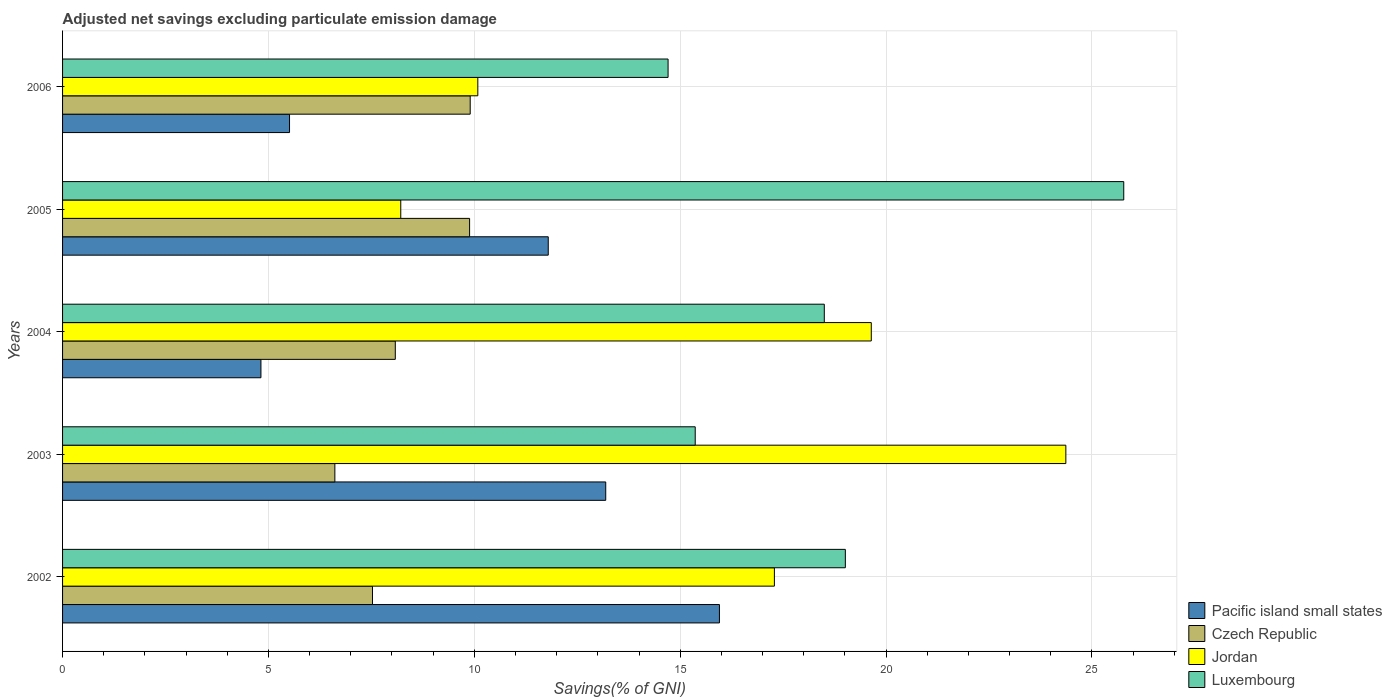How many different coloured bars are there?
Your response must be concise. 4. Are the number of bars per tick equal to the number of legend labels?
Your response must be concise. Yes. How many bars are there on the 1st tick from the top?
Ensure brevity in your answer.  4. What is the adjusted net savings in Luxembourg in 2003?
Make the answer very short. 15.36. Across all years, what is the maximum adjusted net savings in Luxembourg?
Offer a terse response. 25.77. Across all years, what is the minimum adjusted net savings in Czech Republic?
Offer a very short reply. 6.61. What is the total adjusted net savings in Czech Republic in the graph?
Your response must be concise. 42.01. What is the difference between the adjusted net savings in Jordan in 2002 and that in 2003?
Ensure brevity in your answer.  -7.08. What is the difference between the adjusted net savings in Jordan in 2003 and the adjusted net savings in Luxembourg in 2002?
Offer a terse response. 5.36. What is the average adjusted net savings in Jordan per year?
Your answer should be very brief. 15.92. In the year 2004, what is the difference between the adjusted net savings in Luxembourg and adjusted net savings in Pacific island small states?
Offer a terse response. 13.68. In how many years, is the adjusted net savings in Pacific island small states greater than 16 %?
Give a very brief answer. 0. What is the ratio of the adjusted net savings in Luxembourg in 2004 to that in 2005?
Make the answer very short. 0.72. What is the difference between the highest and the second highest adjusted net savings in Czech Republic?
Your response must be concise. 0.01. What is the difference between the highest and the lowest adjusted net savings in Luxembourg?
Make the answer very short. 11.07. In how many years, is the adjusted net savings in Czech Republic greater than the average adjusted net savings in Czech Republic taken over all years?
Offer a very short reply. 2. Is the sum of the adjusted net savings in Pacific island small states in 2004 and 2005 greater than the maximum adjusted net savings in Luxembourg across all years?
Provide a succinct answer. No. What does the 3rd bar from the top in 2006 represents?
Offer a very short reply. Czech Republic. What does the 4th bar from the bottom in 2004 represents?
Make the answer very short. Luxembourg. Are all the bars in the graph horizontal?
Make the answer very short. Yes. How many years are there in the graph?
Make the answer very short. 5. Are the values on the major ticks of X-axis written in scientific E-notation?
Keep it short and to the point. No. Does the graph contain any zero values?
Give a very brief answer. No. Where does the legend appear in the graph?
Give a very brief answer. Bottom right. How many legend labels are there?
Offer a terse response. 4. What is the title of the graph?
Ensure brevity in your answer.  Adjusted net savings excluding particulate emission damage. Does "Tuvalu" appear as one of the legend labels in the graph?
Keep it short and to the point. No. What is the label or title of the X-axis?
Your answer should be very brief. Savings(% of GNI). What is the label or title of the Y-axis?
Your answer should be very brief. Years. What is the Savings(% of GNI) in Pacific island small states in 2002?
Make the answer very short. 15.95. What is the Savings(% of GNI) of Czech Republic in 2002?
Provide a succinct answer. 7.53. What is the Savings(% of GNI) of Jordan in 2002?
Your answer should be compact. 17.29. What is the Savings(% of GNI) in Luxembourg in 2002?
Offer a terse response. 19.01. What is the Savings(% of GNI) in Pacific island small states in 2003?
Your response must be concise. 13.19. What is the Savings(% of GNI) of Czech Republic in 2003?
Provide a short and direct response. 6.61. What is the Savings(% of GNI) in Jordan in 2003?
Make the answer very short. 24.37. What is the Savings(% of GNI) of Luxembourg in 2003?
Your response must be concise. 15.36. What is the Savings(% of GNI) of Pacific island small states in 2004?
Provide a succinct answer. 4.82. What is the Savings(% of GNI) of Czech Republic in 2004?
Make the answer very short. 8.08. What is the Savings(% of GNI) of Jordan in 2004?
Make the answer very short. 19.64. What is the Savings(% of GNI) of Luxembourg in 2004?
Your response must be concise. 18.5. What is the Savings(% of GNI) in Pacific island small states in 2005?
Keep it short and to the point. 11.8. What is the Savings(% of GNI) of Czech Republic in 2005?
Offer a terse response. 9.89. What is the Savings(% of GNI) of Jordan in 2005?
Offer a terse response. 8.21. What is the Savings(% of GNI) in Luxembourg in 2005?
Offer a very short reply. 25.77. What is the Savings(% of GNI) of Pacific island small states in 2006?
Make the answer very short. 5.51. What is the Savings(% of GNI) in Czech Republic in 2006?
Give a very brief answer. 9.9. What is the Savings(% of GNI) of Jordan in 2006?
Offer a very short reply. 10.08. What is the Savings(% of GNI) of Luxembourg in 2006?
Give a very brief answer. 14.71. Across all years, what is the maximum Savings(% of GNI) in Pacific island small states?
Make the answer very short. 15.95. Across all years, what is the maximum Savings(% of GNI) of Czech Republic?
Provide a succinct answer. 9.9. Across all years, what is the maximum Savings(% of GNI) of Jordan?
Provide a short and direct response. 24.37. Across all years, what is the maximum Savings(% of GNI) in Luxembourg?
Provide a short and direct response. 25.77. Across all years, what is the minimum Savings(% of GNI) in Pacific island small states?
Make the answer very short. 4.82. Across all years, what is the minimum Savings(% of GNI) of Czech Republic?
Provide a short and direct response. 6.61. Across all years, what is the minimum Savings(% of GNI) in Jordan?
Give a very brief answer. 8.21. Across all years, what is the minimum Savings(% of GNI) of Luxembourg?
Your answer should be compact. 14.71. What is the total Savings(% of GNI) of Pacific island small states in the graph?
Provide a short and direct response. 51.27. What is the total Savings(% of GNI) of Czech Republic in the graph?
Your answer should be very brief. 42.01. What is the total Savings(% of GNI) of Jordan in the graph?
Your answer should be very brief. 79.59. What is the total Savings(% of GNI) in Luxembourg in the graph?
Your answer should be compact. 93.35. What is the difference between the Savings(% of GNI) of Pacific island small states in 2002 and that in 2003?
Your answer should be compact. 2.76. What is the difference between the Savings(% of GNI) of Czech Republic in 2002 and that in 2003?
Offer a terse response. 0.91. What is the difference between the Savings(% of GNI) in Jordan in 2002 and that in 2003?
Keep it short and to the point. -7.08. What is the difference between the Savings(% of GNI) in Luxembourg in 2002 and that in 2003?
Ensure brevity in your answer.  3.65. What is the difference between the Savings(% of GNI) of Pacific island small states in 2002 and that in 2004?
Keep it short and to the point. 11.14. What is the difference between the Savings(% of GNI) of Czech Republic in 2002 and that in 2004?
Offer a terse response. -0.55. What is the difference between the Savings(% of GNI) in Jordan in 2002 and that in 2004?
Provide a succinct answer. -2.35. What is the difference between the Savings(% of GNI) of Luxembourg in 2002 and that in 2004?
Your response must be concise. 0.51. What is the difference between the Savings(% of GNI) in Pacific island small states in 2002 and that in 2005?
Your answer should be compact. 4.16. What is the difference between the Savings(% of GNI) in Czech Republic in 2002 and that in 2005?
Your answer should be very brief. -2.36. What is the difference between the Savings(% of GNI) of Jordan in 2002 and that in 2005?
Your answer should be compact. 9.07. What is the difference between the Savings(% of GNI) of Luxembourg in 2002 and that in 2005?
Offer a terse response. -6.76. What is the difference between the Savings(% of GNI) in Pacific island small states in 2002 and that in 2006?
Provide a succinct answer. 10.44. What is the difference between the Savings(% of GNI) of Czech Republic in 2002 and that in 2006?
Provide a succinct answer. -2.37. What is the difference between the Savings(% of GNI) of Jordan in 2002 and that in 2006?
Offer a terse response. 7.2. What is the difference between the Savings(% of GNI) in Luxembourg in 2002 and that in 2006?
Give a very brief answer. 4.31. What is the difference between the Savings(% of GNI) of Pacific island small states in 2003 and that in 2004?
Give a very brief answer. 8.37. What is the difference between the Savings(% of GNI) in Czech Republic in 2003 and that in 2004?
Provide a succinct answer. -1.47. What is the difference between the Savings(% of GNI) in Jordan in 2003 and that in 2004?
Make the answer very short. 4.73. What is the difference between the Savings(% of GNI) of Luxembourg in 2003 and that in 2004?
Your answer should be compact. -3.13. What is the difference between the Savings(% of GNI) in Pacific island small states in 2003 and that in 2005?
Your response must be concise. 1.4. What is the difference between the Savings(% of GNI) of Czech Republic in 2003 and that in 2005?
Offer a terse response. -3.27. What is the difference between the Savings(% of GNI) in Jordan in 2003 and that in 2005?
Give a very brief answer. 16.15. What is the difference between the Savings(% of GNI) in Luxembourg in 2003 and that in 2005?
Your answer should be compact. -10.41. What is the difference between the Savings(% of GNI) in Pacific island small states in 2003 and that in 2006?
Offer a terse response. 7.68. What is the difference between the Savings(% of GNI) of Czech Republic in 2003 and that in 2006?
Give a very brief answer. -3.29. What is the difference between the Savings(% of GNI) of Jordan in 2003 and that in 2006?
Your response must be concise. 14.28. What is the difference between the Savings(% of GNI) of Luxembourg in 2003 and that in 2006?
Your answer should be very brief. 0.66. What is the difference between the Savings(% of GNI) in Pacific island small states in 2004 and that in 2005?
Your response must be concise. -6.98. What is the difference between the Savings(% of GNI) in Czech Republic in 2004 and that in 2005?
Make the answer very short. -1.8. What is the difference between the Savings(% of GNI) in Jordan in 2004 and that in 2005?
Your response must be concise. 11.43. What is the difference between the Savings(% of GNI) of Luxembourg in 2004 and that in 2005?
Offer a terse response. -7.27. What is the difference between the Savings(% of GNI) in Pacific island small states in 2004 and that in 2006?
Your answer should be compact. -0.69. What is the difference between the Savings(% of GNI) in Czech Republic in 2004 and that in 2006?
Your response must be concise. -1.82. What is the difference between the Savings(% of GNI) of Jordan in 2004 and that in 2006?
Offer a terse response. 9.56. What is the difference between the Savings(% of GNI) in Luxembourg in 2004 and that in 2006?
Provide a succinct answer. 3.79. What is the difference between the Savings(% of GNI) in Pacific island small states in 2005 and that in 2006?
Provide a succinct answer. 6.28. What is the difference between the Savings(% of GNI) in Czech Republic in 2005 and that in 2006?
Your response must be concise. -0.01. What is the difference between the Savings(% of GNI) of Jordan in 2005 and that in 2006?
Give a very brief answer. -1.87. What is the difference between the Savings(% of GNI) in Luxembourg in 2005 and that in 2006?
Make the answer very short. 11.07. What is the difference between the Savings(% of GNI) in Pacific island small states in 2002 and the Savings(% of GNI) in Czech Republic in 2003?
Your answer should be very brief. 9.34. What is the difference between the Savings(% of GNI) of Pacific island small states in 2002 and the Savings(% of GNI) of Jordan in 2003?
Make the answer very short. -8.41. What is the difference between the Savings(% of GNI) in Pacific island small states in 2002 and the Savings(% of GNI) in Luxembourg in 2003?
Offer a terse response. 0.59. What is the difference between the Savings(% of GNI) in Czech Republic in 2002 and the Savings(% of GNI) in Jordan in 2003?
Your response must be concise. -16.84. What is the difference between the Savings(% of GNI) of Czech Republic in 2002 and the Savings(% of GNI) of Luxembourg in 2003?
Ensure brevity in your answer.  -7.84. What is the difference between the Savings(% of GNI) in Jordan in 2002 and the Savings(% of GNI) in Luxembourg in 2003?
Provide a succinct answer. 1.92. What is the difference between the Savings(% of GNI) in Pacific island small states in 2002 and the Savings(% of GNI) in Czech Republic in 2004?
Offer a terse response. 7.87. What is the difference between the Savings(% of GNI) of Pacific island small states in 2002 and the Savings(% of GNI) of Jordan in 2004?
Ensure brevity in your answer.  -3.69. What is the difference between the Savings(% of GNI) of Pacific island small states in 2002 and the Savings(% of GNI) of Luxembourg in 2004?
Your response must be concise. -2.55. What is the difference between the Savings(% of GNI) in Czech Republic in 2002 and the Savings(% of GNI) in Jordan in 2004?
Keep it short and to the point. -12.11. What is the difference between the Savings(% of GNI) in Czech Republic in 2002 and the Savings(% of GNI) in Luxembourg in 2004?
Give a very brief answer. -10.97. What is the difference between the Savings(% of GNI) of Jordan in 2002 and the Savings(% of GNI) of Luxembourg in 2004?
Make the answer very short. -1.21. What is the difference between the Savings(% of GNI) of Pacific island small states in 2002 and the Savings(% of GNI) of Czech Republic in 2005?
Provide a short and direct response. 6.07. What is the difference between the Savings(% of GNI) of Pacific island small states in 2002 and the Savings(% of GNI) of Jordan in 2005?
Give a very brief answer. 7.74. What is the difference between the Savings(% of GNI) of Pacific island small states in 2002 and the Savings(% of GNI) of Luxembourg in 2005?
Your response must be concise. -9.82. What is the difference between the Savings(% of GNI) in Czech Republic in 2002 and the Savings(% of GNI) in Jordan in 2005?
Offer a very short reply. -0.69. What is the difference between the Savings(% of GNI) of Czech Republic in 2002 and the Savings(% of GNI) of Luxembourg in 2005?
Give a very brief answer. -18.25. What is the difference between the Savings(% of GNI) of Jordan in 2002 and the Savings(% of GNI) of Luxembourg in 2005?
Keep it short and to the point. -8.48. What is the difference between the Savings(% of GNI) of Pacific island small states in 2002 and the Savings(% of GNI) of Czech Republic in 2006?
Provide a succinct answer. 6.05. What is the difference between the Savings(% of GNI) in Pacific island small states in 2002 and the Savings(% of GNI) in Jordan in 2006?
Provide a short and direct response. 5.87. What is the difference between the Savings(% of GNI) of Pacific island small states in 2002 and the Savings(% of GNI) of Luxembourg in 2006?
Offer a terse response. 1.25. What is the difference between the Savings(% of GNI) of Czech Republic in 2002 and the Savings(% of GNI) of Jordan in 2006?
Your answer should be very brief. -2.56. What is the difference between the Savings(% of GNI) in Czech Republic in 2002 and the Savings(% of GNI) in Luxembourg in 2006?
Offer a terse response. -7.18. What is the difference between the Savings(% of GNI) in Jordan in 2002 and the Savings(% of GNI) in Luxembourg in 2006?
Provide a short and direct response. 2.58. What is the difference between the Savings(% of GNI) of Pacific island small states in 2003 and the Savings(% of GNI) of Czech Republic in 2004?
Ensure brevity in your answer.  5.11. What is the difference between the Savings(% of GNI) in Pacific island small states in 2003 and the Savings(% of GNI) in Jordan in 2004?
Make the answer very short. -6.45. What is the difference between the Savings(% of GNI) in Pacific island small states in 2003 and the Savings(% of GNI) in Luxembourg in 2004?
Make the answer very short. -5.31. What is the difference between the Savings(% of GNI) in Czech Republic in 2003 and the Savings(% of GNI) in Jordan in 2004?
Ensure brevity in your answer.  -13.03. What is the difference between the Savings(% of GNI) in Czech Republic in 2003 and the Savings(% of GNI) in Luxembourg in 2004?
Provide a succinct answer. -11.89. What is the difference between the Savings(% of GNI) in Jordan in 2003 and the Savings(% of GNI) in Luxembourg in 2004?
Offer a terse response. 5.87. What is the difference between the Savings(% of GNI) of Pacific island small states in 2003 and the Savings(% of GNI) of Czech Republic in 2005?
Ensure brevity in your answer.  3.31. What is the difference between the Savings(% of GNI) of Pacific island small states in 2003 and the Savings(% of GNI) of Jordan in 2005?
Your answer should be very brief. 4.98. What is the difference between the Savings(% of GNI) of Pacific island small states in 2003 and the Savings(% of GNI) of Luxembourg in 2005?
Provide a succinct answer. -12.58. What is the difference between the Savings(% of GNI) of Czech Republic in 2003 and the Savings(% of GNI) of Jordan in 2005?
Offer a very short reply. -1.6. What is the difference between the Savings(% of GNI) in Czech Republic in 2003 and the Savings(% of GNI) in Luxembourg in 2005?
Your answer should be compact. -19.16. What is the difference between the Savings(% of GNI) of Jordan in 2003 and the Savings(% of GNI) of Luxembourg in 2005?
Your response must be concise. -1.41. What is the difference between the Savings(% of GNI) of Pacific island small states in 2003 and the Savings(% of GNI) of Czech Republic in 2006?
Provide a succinct answer. 3.29. What is the difference between the Savings(% of GNI) of Pacific island small states in 2003 and the Savings(% of GNI) of Jordan in 2006?
Offer a terse response. 3.11. What is the difference between the Savings(% of GNI) of Pacific island small states in 2003 and the Savings(% of GNI) of Luxembourg in 2006?
Your answer should be compact. -1.51. What is the difference between the Savings(% of GNI) in Czech Republic in 2003 and the Savings(% of GNI) in Jordan in 2006?
Your answer should be very brief. -3.47. What is the difference between the Savings(% of GNI) in Czech Republic in 2003 and the Savings(% of GNI) in Luxembourg in 2006?
Keep it short and to the point. -8.09. What is the difference between the Savings(% of GNI) of Jordan in 2003 and the Savings(% of GNI) of Luxembourg in 2006?
Keep it short and to the point. 9.66. What is the difference between the Savings(% of GNI) of Pacific island small states in 2004 and the Savings(% of GNI) of Czech Republic in 2005?
Your answer should be compact. -5.07. What is the difference between the Savings(% of GNI) in Pacific island small states in 2004 and the Savings(% of GNI) in Jordan in 2005?
Provide a succinct answer. -3.4. What is the difference between the Savings(% of GNI) in Pacific island small states in 2004 and the Savings(% of GNI) in Luxembourg in 2005?
Make the answer very short. -20.95. What is the difference between the Savings(% of GNI) of Czech Republic in 2004 and the Savings(% of GNI) of Jordan in 2005?
Provide a short and direct response. -0.13. What is the difference between the Savings(% of GNI) of Czech Republic in 2004 and the Savings(% of GNI) of Luxembourg in 2005?
Offer a terse response. -17.69. What is the difference between the Savings(% of GNI) in Jordan in 2004 and the Savings(% of GNI) in Luxembourg in 2005?
Provide a succinct answer. -6.13. What is the difference between the Savings(% of GNI) in Pacific island small states in 2004 and the Savings(% of GNI) in Czech Republic in 2006?
Ensure brevity in your answer.  -5.08. What is the difference between the Savings(% of GNI) of Pacific island small states in 2004 and the Savings(% of GNI) of Jordan in 2006?
Offer a terse response. -5.27. What is the difference between the Savings(% of GNI) in Pacific island small states in 2004 and the Savings(% of GNI) in Luxembourg in 2006?
Provide a short and direct response. -9.89. What is the difference between the Savings(% of GNI) in Czech Republic in 2004 and the Savings(% of GNI) in Jordan in 2006?
Ensure brevity in your answer.  -2. What is the difference between the Savings(% of GNI) in Czech Republic in 2004 and the Savings(% of GNI) in Luxembourg in 2006?
Provide a succinct answer. -6.62. What is the difference between the Savings(% of GNI) in Jordan in 2004 and the Savings(% of GNI) in Luxembourg in 2006?
Provide a succinct answer. 4.93. What is the difference between the Savings(% of GNI) of Pacific island small states in 2005 and the Savings(% of GNI) of Czech Republic in 2006?
Ensure brevity in your answer.  1.9. What is the difference between the Savings(% of GNI) in Pacific island small states in 2005 and the Savings(% of GNI) in Jordan in 2006?
Offer a very short reply. 1.71. What is the difference between the Savings(% of GNI) in Pacific island small states in 2005 and the Savings(% of GNI) in Luxembourg in 2006?
Make the answer very short. -2.91. What is the difference between the Savings(% of GNI) of Czech Republic in 2005 and the Savings(% of GNI) of Jordan in 2006?
Ensure brevity in your answer.  -0.2. What is the difference between the Savings(% of GNI) of Czech Republic in 2005 and the Savings(% of GNI) of Luxembourg in 2006?
Give a very brief answer. -4.82. What is the difference between the Savings(% of GNI) of Jordan in 2005 and the Savings(% of GNI) of Luxembourg in 2006?
Make the answer very short. -6.49. What is the average Savings(% of GNI) of Pacific island small states per year?
Give a very brief answer. 10.25. What is the average Savings(% of GNI) in Czech Republic per year?
Your answer should be compact. 8.4. What is the average Savings(% of GNI) of Jordan per year?
Provide a succinct answer. 15.92. What is the average Savings(% of GNI) of Luxembourg per year?
Give a very brief answer. 18.67. In the year 2002, what is the difference between the Savings(% of GNI) of Pacific island small states and Savings(% of GNI) of Czech Republic?
Keep it short and to the point. 8.43. In the year 2002, what is the difference between the Savings(% of GNI) in Pacific island small states and Savings(% of GNI) in Jordan?
Provide a short and direct response. -1.33. In the year 2002, what is the difference between the Savings(% of GNI) in Pacific island small states and Savings(% of GNI) in Luxembourg?
Ensure brevity in your answer.  -3.06. In the year 2002, what is the difference between the Savings(% of GNI) in Czech Republic and Savings(% of GNI) in Jordan?
Ensure brevity in your answer.  -9.76. In the year 2002, what is the difference between the Savings(% of GNI) in Czech Republic and Savings(% of GNI) in Luxembourg?
Provide a succinct answer. -11.48. In the year 2002, what is the difference between the Savings(% of GNI) in Jordan and Savings(% of GNI) in Luxembourg?
Ensure brevity in your answer.  -1.72. In the year 2003, what is the difference between the Savings(% of GNI) in Pacific island small states and Savings(% of GNI) in Czech Republic?
Your answer should be compact. 6.58. In the year 2003, what is the difference between the Savings(% of GNI) of Pacific island small states and Savings(% of GNI) of Jordan?
Your answer should be compact. -11.17. In the year 2003, what is the difference between the Savings(% of GNI) in Pacific island small states and Savings(% of GNI) in Luxembourg?
Ensure brevity in your answer.  -2.17. In the year 2003, what is the difference between the Savings(% of GNI) of Czech Republic and Savings(% of GNI) of Jordan?
Ensure brevity in your answer.  -17.75. In the year 2003, what is the difference between the Savings(% of GNI) in Czech Republic and Savings(% of GNI) in Luxembourg?
Keep it short and to the point. -8.75. In the year 2003, what is the difference between the Savings(% of GNI) of Jordan and Savings(% of GNI) of Luxembourg?
Give a very brief answer. 9. In the year 2004, what is the difference between the Savings(% of GNI) of Pacific island small states and Savings(% of GNI) of Czech Republic?
Offer a very short reply. -3.26. In the year 2004, what is the difference between the Savings(% of GNI) in Pacific island small states and Savings(% of GNI) in Jordan?
Provide a succinct answer. -14.82. In the year 2004, what is the difference between the Savings(% of GNI) in Pacific island small states and Savings(% of GNI) in Luxembourg?
Give a very brief answer. -13.68. In the year 2004, what is the difference between the Savings(% of GNI) in Czech Republic and Savings(% of GNI) in Jordan?
Keep it short and to the point. -11.56. In the year 2004, what is the difference between the Savings(% of GNI) of Czech Republic and Savings(% of GNI) of Luxembourg?
Keep it short and to the point. -10.42. In the year 2004, what is the difference between the Savings(% of GNI) of Jordan and Savings(% of GNI) of Luxembourg?
Your answer should be very brief. 1.14. In the year 2005, what is the difference between the Savings(% of GNI) of Pacific island small states and Savings(% of GNI) of Czech Republic?
Your response must be concise. 1.91. In the year 2005, what is the difference between the Savings(% of GNI) in Pacific island small states and Savings(% of GNI) in Jordan?
Ensure brevity in your answer.  3.58. In the year 2005, what is the difference between the Savings(% of GNI) of Pacific island small states and Savings(% of GNI) of Luxembourg?
Offer a very short reply. -13.98. In the year 2005, what is the difference between the Savings(% of GNI) of Czech Republic and Savings(% of GNI) of Jordan?
Ensure brevity in your answer.  1.67. In the year 2005, what is the difference between the Savings(% of GNI) of Czech Republic and Savings(% of GNI) of Luxembourg?
Keep it short and to the point. -15.89. In the year 2005, what is the difference between the Savings(% of GNI) of Jordan and Savings(% of GNI) of Luxembourg?
Your answer should be very brief. -17.56. In the year 2006, what is the difference between the Savings(% of GNI) in Pacific island small states and Savings(% of GNI) in Czech Republic?
Offer a terse response. -4.39. In the year 2006, what is the difference between the Savings(% of GNI) in Pacific island small states and Savings(% of GNI) in Jordan?
Provide a succinct answer. -4.57. In the year 2006, what is the difference between the Savings(% of GNI) of Pacific island small states and Savings(% of GNI) of Luxembourg?
Ensure brevity in your answer.  -9.19. In the year 2006, what is the difference between the Savings(% of GNI) in Czech Republic and Savings(% of GNI) in Jordan?
Your response must be concise. -0.18. In the year 2006, what is the difference between the Savings(% of GNI) in Czech Republic and Savings(% of GNI) in Luxembourg?
Provide a succinct answer. -4.81. In the year 2006, what is the difference between the Savings(% of GNI) of Jordan and Savings(% of GNI) of Luxembourg?
Give a very brief answer. -4.62. What is the ratio of the Savings(% of GNI) in Pacific island small states in 2002 to that in 2003?
Keep it short and to the point. 1.21. What is the ratio of the Savings(% of GNI) in Czech Republic in 2002 to that in 2003?
Make the answer very short. 1.14. What is the ratio of the Savings(% of GNI) of Jordan in 2002 to that in 2003?
Your answer should be very brief. 0.71. What is the ratio of the Savings(% of GNI) in Luxembourg in 2002 to that in 2003?
Provide a short and direct response. 1.24. What is the ratio of the Savings(% of GNI) of Pacific island small states in 2002 to that in 2004?
Make the answer very short. 3.31. What is the ratio of the Savings(% of GNI) in Czech Republic in 2002 to that in 2004?
Your answer should be compact. 0.93. What is the ratio of the Savings(% of GNI) in Jordan in 2002 to that in 2004?
Keep it short and to the point. 0.88. What is the ratio of the Savings(% of GNI) in Luxembourg in 2002 to that in 2004?
Your answer should be very brief. 1.03. What is the ratio of the Savings(% of GNI) of Pacific island small states in 2002 to that in 2005?
Offer a terse response. 1.35. What is the ratio of the Savings(% of GNI) of Czech Republic in 2002 to that in 2005?
Offer a very short reply. 0.76. What is the ratio of the Savings(% of GNI) of Jordan in 2002 to that in 2005?
Make the answer very short. 2.1. What is the ratio of the Savings(% of GNI) in Luxembourg in 2002 to that in 2005?
Keep it short and to the point. 0.74. What is the ratio of the Savings(% of GNI) of Pacific island small states in 2002 to that in 2006?
Give a very brief answer. 2.89. What is the ratio of the Savings(% of GNI) in Czech Republic in 2002 to that in 2006?
Ensure brevity in your answer.  0.76. What is the ratio of the Savings(% of GNI) in Jordan in 2002 to that in 2006?
Offer a terse response. 1.71. What is the ratio of the Savings(% of GNI) of Luxembourg in 2002 to that in 2006?
Your response must be concise. 1.29. What is the ratio of the Savings(% of GNI) of Pacific island small states in 2003 to that in 2004?
Make the answer very short. 2.74. What is the ratio of the Savings(% of GNI) in Czech Republic in 2003 to that in 2004?
Offer a terse response. 0.82. What is the ratio of the Savings(% of GNI) of Jordan in 2003 to that in 2004?
Offer a very short reply. 1.24. What is the ratio of the Savings(% of GNI) of Luxembourg in 2003 to that in 2004?
Keep it short and to the point. 0.83. What is the ratio of the Savings(% of GNI) in Pacific island small states in 2003 to that in 2005?
Make the answer very short. 1.12. What is the ratio of the Savings(% of GNI) in Czech Republic in 2003 to that in 2005?
Provide a succinct answer. 0.67. What is the ratio of the Savings(% of GNI) of Jordan in 2003 to that in 2005?
Make the answer very short. 2.97. What is the ratio of the Savings(% of GNI) in Luxembourg in 2003 to that in 2005?
Keep it short and to the point. 0.6. What is the ratio of the Savings(% of GNI) in Pacific island small states in 2003 to that in 2006?
Ensure brevity in your answer.  2.39. What is the ratio of the Savings(% of GNI) in Czech Republic in 2003 to that in 2006?
Your answer should be very brief. 0.67. What is the ratio of the Savings(% of GNI) in Jordan in 2003 to that in 2006?
Offer a terse response. 2.42. What is the ratio of the Savings(% of GNI) in Luxembourg in 2003 to that in 2006?
Give a very brief answer. 1.04. What is the ratio of the Savings(% of GNI) in Pacific island small states in 2004 to that in 2005?
Ensure brevity in your answer.  0.41. What is the ratio of the Savings(% of GNI) of Czech Republic in 2004 to that in 2005?
Provide a short and direct response. 0.82. What is the ratio of the Savings(% of GNI) in Jordan in 2004 to that in 2005?
Provide a short and direct response. 2.39. What is the ratio of the Savings(% of GNI) of Luxembourg in 2004 to that in 2005?
Ensure brevity in your answer.  0.72. What is the ratio of the Savings(% of GNI) in Pacific island small states in 2004 to that in 2006?
Your answer should be compact. 0.87. What is the ratio of the Savings(% of GNI) in Czech Republic in 2004 to that in 2006?
Ensure brevity in your answer.  0.82. What is the ratio of the Savings(% of GNI) of Jordan in 2004 to that in 2006?
Give a very brief answer. 1.95. What is the ratio of the Savings(% of GNI) of Luxembourg in 2004 to that in 2006?
Your response must be concise. 1.26. What is the ratio of the Savings(% of GNI) of Pacific island small states in 2005 to that in 2006?
Your answer should be compact. 2.14. What is the ratio of the Savings(% of GNI) in Czech Republic in 2005 to that in 2006?
Your response must be concise. 1. What is the ratio of the Savings(% of GNI) in Jordan in 2005 to that in 2006?
Keep it short and to the point. 0.81. What is the ratio of the Savings(% of GNI) of Luxembourg in 2005 to that in 2006?
Offer a terse response. 1.75. What is the difference between the highest and the second highest Savings(% of GNI) of Pacific island small states?
Your answer should be compact. 2.76. What is the difference between the highest and the second highest Savings(% of GNI) of Czech Republic?
Provide a succinct answer. 0.01. What is the difference between the highest and the second highest Savings(% of GNI) of Jordan?
Your response must be concise. 4.73. What is the difference between the highest and the second highest Savings(% of GNI) of Luxembourg?
Offer a terse response. 6.76. What is the difference between the highest and the lowest Savings(% of GNI) of Pacific island small states?
Your response must be concise. 11.14. What is the difference between the highest and the lowest Savings(% of GNI) of Czech Republic?
Offer a terse response. 3.29. What is the difference between the highest and the lowest Savings(% of GNI) of Jordan?
Your answer should be compact. 16.15. What is the difference between the highest and the lowest Savings(% of GNI) of Luxembourg?
Make the answer very short. 11.07. 